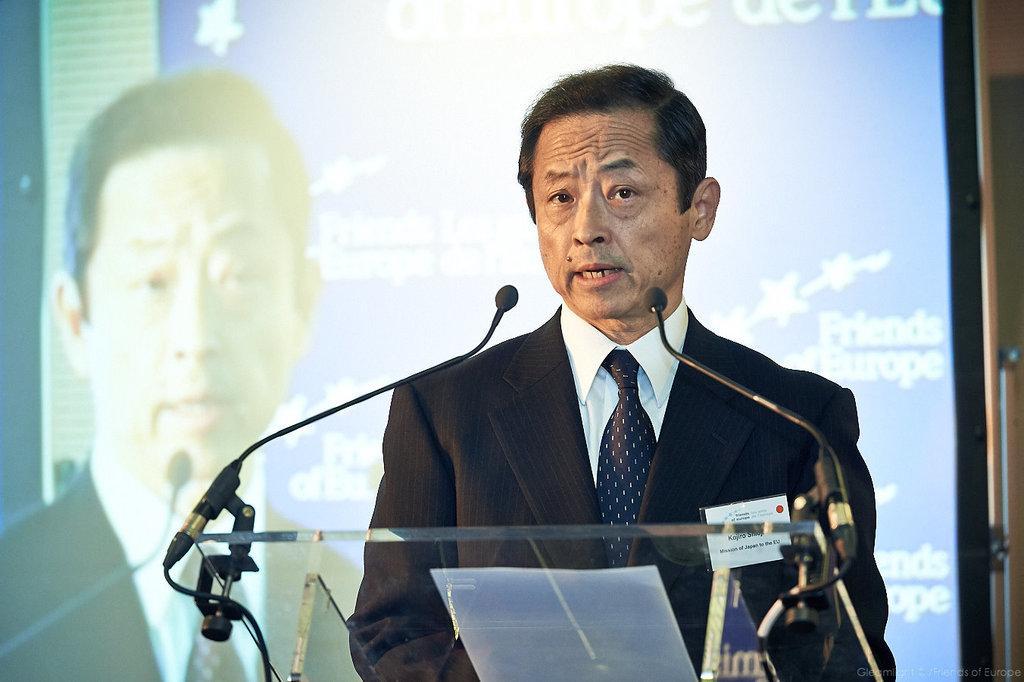Please provide a concise description of this image. This image consists of a man wearing a suit. In front of him, there are mice fixed to the podium. In the background, we can see a screen. 